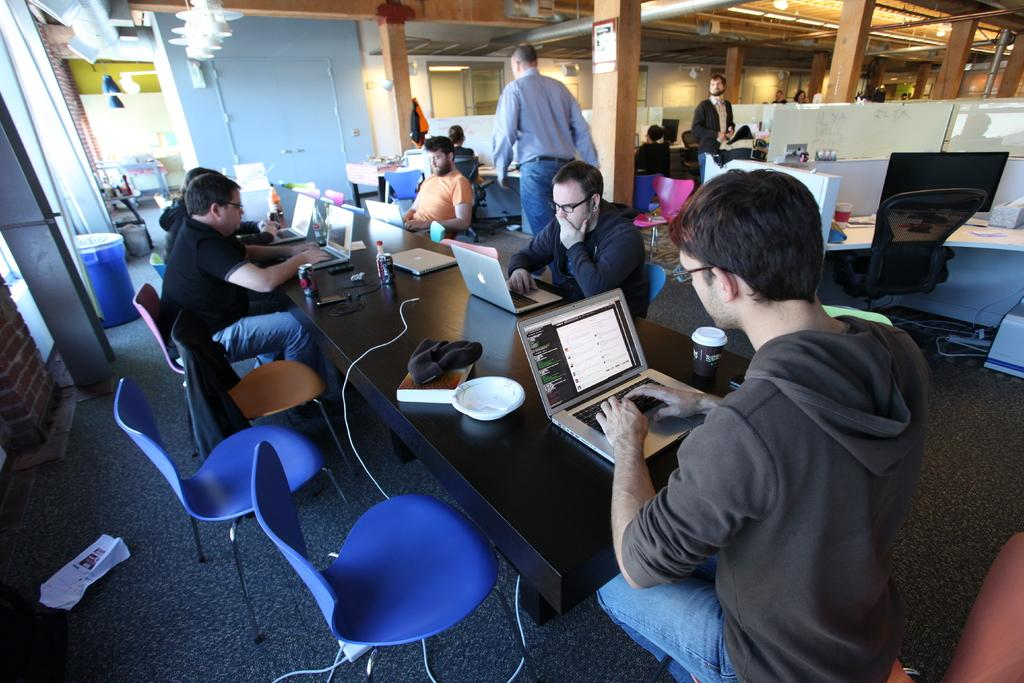What are the people in the image doing around the table? The people are sitting around a table and using laptops in the image. What activity are the people engaged in? The people are working in the image. What can be seen in the background of the image? There are pillars, a drum, and a wall in the background of the image. What type of silk is being used to create the guide in the image? There is no silk or guide present in the image. What is the hammer being used for in the image? There is no hammer present in the image. 